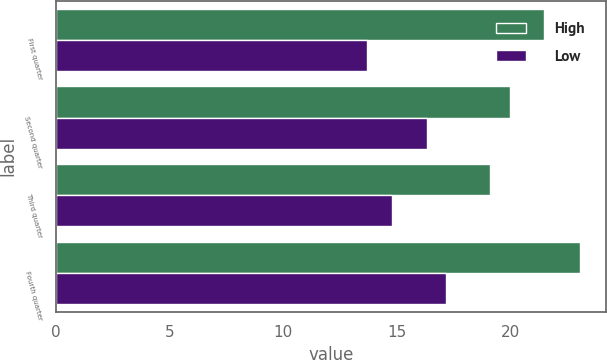Convert chart to OTSL. <chart><loc_0><loc_0><loc_500><loc_500><stacked_bar_chart><ecel><fcel>First quarter<fcel>Second quarter<fcel>Third quarter<fcel>Fourth quarter<nl><fcel>High<fcel>21.45<fcel>19.98<fcel>19.09<fcel>23.03<nl><fcel>Low<fcel>13.67<fcel>16.32<fcel>14.79<fcel>17.17<nl></chart> 